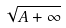Convert formula to latex. <formula><loc_0><loc_0><loc_500><loc_500>\sqrt { A + \infty }</formula> 